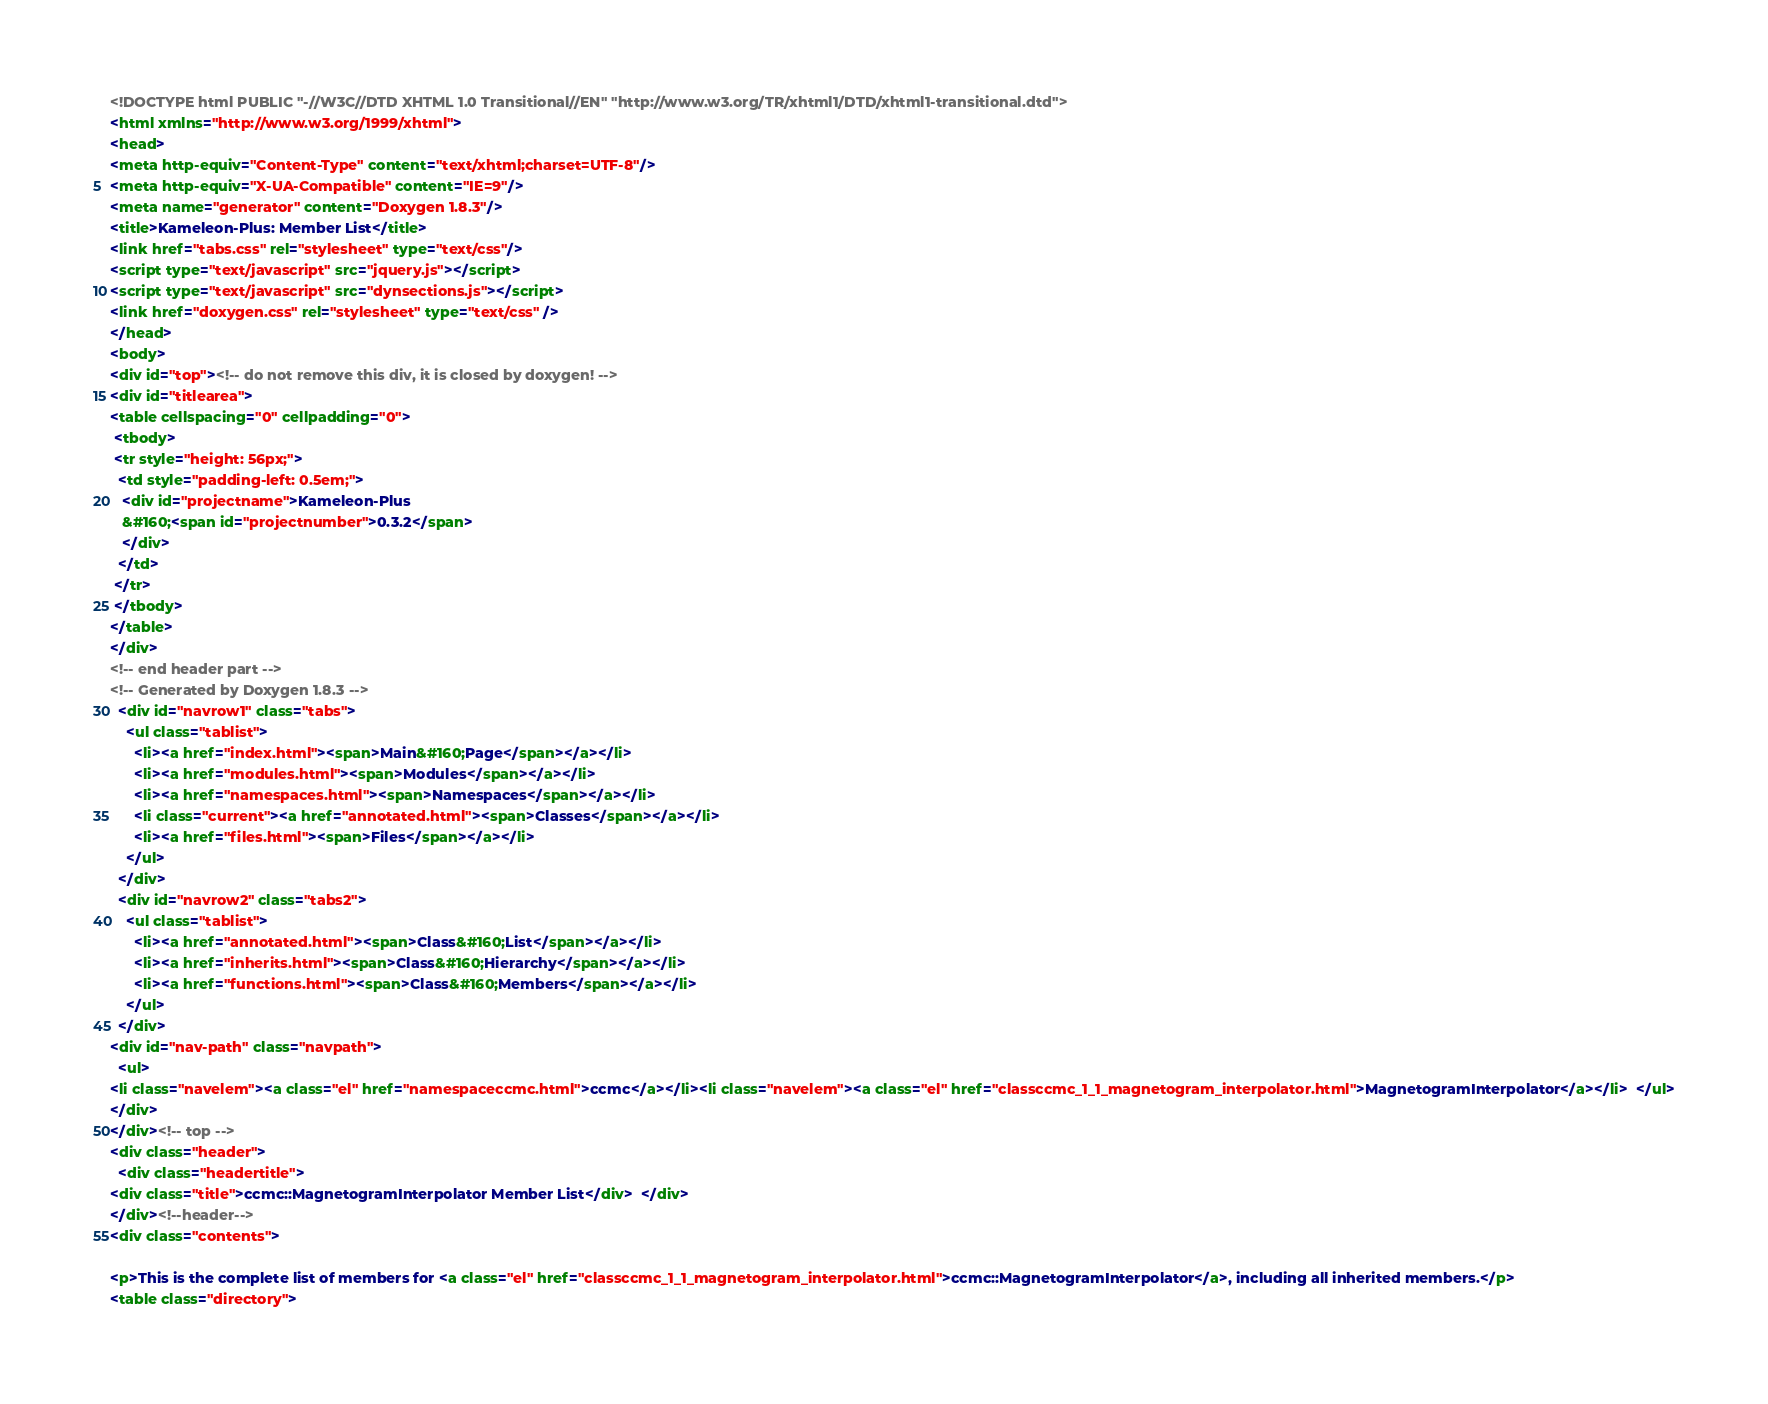Convert code to text. <code><loc_0><loc_0><loc_500><loc_500><_HTML_><!DOCTYPE html PUBLIC "-//W3C//DTD XHTML 1.0 Transitional//EN" "http://www.w3.org/TR/xhtml1/DTD/xhtml1-transitional.dtd">
<html xmlns="http://www.w3.org/1999/xhtml">
<head>
<meta http-equiv="Content-Type" content="text/xhtml;charset=UTF-8"/>
<meta http-equiv="X-UA-Compatible" content="IE=9"/>
<meta name="generator" content="Doxygen 1.8.3"/>
<title>Kameleon-Plus: Member List</title>
<link href="tabs.css" rel="stylesheet" type="text/css"/>
<script type="text/javascript" src="jquery.js"></script>
<script type="text/javascript" src="dynsections.js"></script>
<link href="doxygen.css" rel="stylesheet" type="text/css" />
</head>
<body>
<div id="top"><!-- do not remove this div, it is closed by doxygen! -->
<div id="titlearea">
<table cellspacing="0" cellpadding="0">
 <tbody>
 <tr style="height: 56px;">
  <td style="padding-left: 0.5em;">
   <div id="projectname">Kameleon-Plus
   &#160;<span id="projectnumber">0.3.2</span>
   </div>
  </td>
 </tr>
 </tbody>
</table>
</div>
<!-- end header part -->
<!-- Generated by Doxygen 1.8.3 -->
  <div id="navrow1" class="tabs">
    <ul class="tablist">
      <li><a href="index.html"><span>Main&#160;Page</span></a></li>
      <li><a href="modules.html"><span>Modules</span></a></li>
      <li><a href="namespaces.html"><span>Namespaces</span></a></li>
      <li class="current"><a href="annotated.html"><span>Classes</span></a></li>
      <li><a href="files.html"><span>Files</span></a></li>
    </ul>
  </div>
  <div id="navrow2" class="tabs2">
    <ul class="tablist">
      <li><a href="annotated.html"><span>Class&#160;List</span></a></li>
      <li><a href="inherits.html"><span>Class&#160;Hierarchy</span></a></li>
      <li><a href="functions.html"><span>Class&#160;Members</span></a></li>
    </ul>
  </div>
<div id="nav-path" class="navpath">
  <ul>
<li class="navelem"><a class="el" href="namespaceccmc.html">ccmc</a></li><li class="navelem"><a class="el" href="classccmc_1_1_magnetogram_interpolator.html">MagnetogramInterpolator</a></li>  </ul>
</div>
</div><!-- top -->
<div class="header">
  <div class="headertitle">
<div class="title">ccmc::MagnetogramInterpolator Member List</div>  </div>
</div><!--header-->
<div class="contents">

<p>This is the complete list of members for <a class="el" href="classccmc_1_1_magnetogram_interpolator.html">ccmc::MagnetogramInterpolator</a>, including all inherited members.</p>
<table class="directory"></code> 